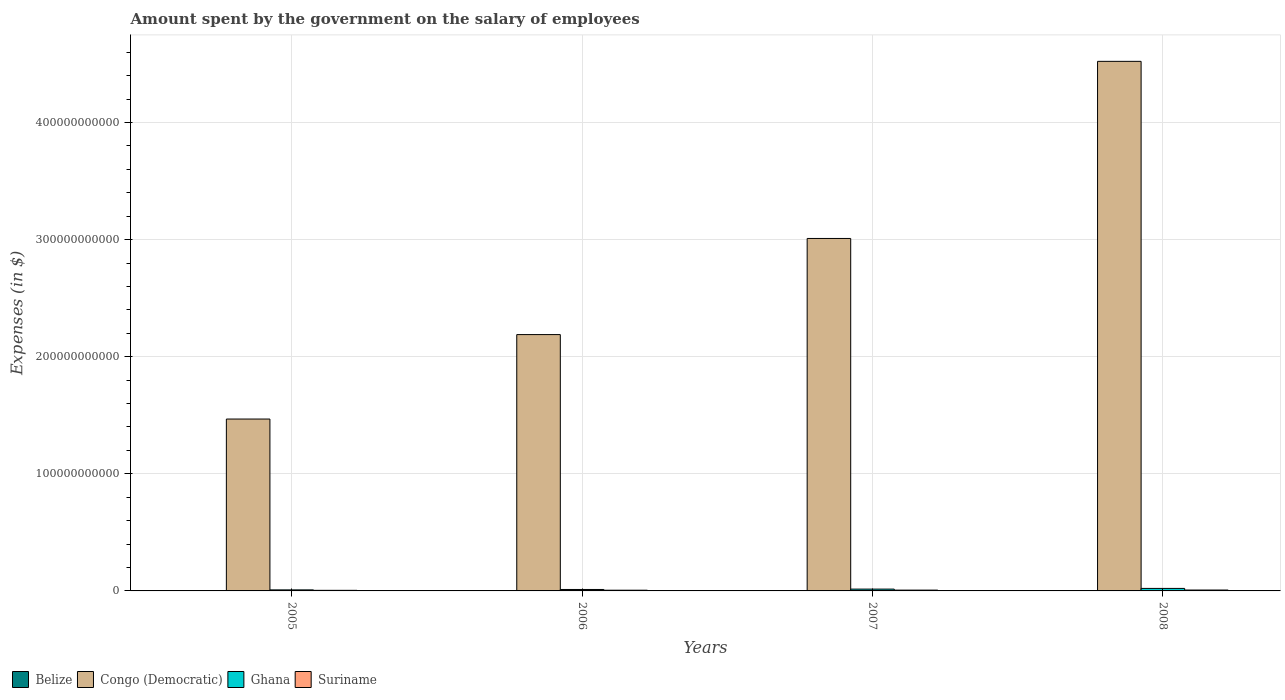How many different coloured bars are there?
Offer a terse response. 4. How many groups of bars are there?
Your answer should be compact. 4. Are the number of bars per tick equal to the number of legend labels?
Your answer should be compact. Yes. Are the number of bars on each tick of the X-axis equal?
Your answer should be very brief. Yes. How many bars are there on the 4th tick from the left?
Provide a short and direct response. 4. How many bars are there on the 4th tick from the right?
Your answer should be compact. 4. What is the amount spent on the salary of employees by the government in Suriname in 2006?
Your answer should be compact. 6.03e+08. Across all years, what is the maximum amount spent on the salary of employees by the government in Ghana?
Your answer should be compact. 2.15e+09. Across all years, what is the minimum amount spent on the salary of employees by the government in Congo (Democratic)?
Make the answer very short. 1.47e+11. What is the total amount spent on the salary of employees by the government in Congo (Democratic) in the graph?
Provide a succinct answer. 1.12e+12. What is the difference between the amount spent on the salary of employees by the government in Suriname in 2006 and that in 2008?
Provide a succinct answer. -1.56e+08. What is the difference between the amount spent on the salary of employees by the government in Suriname in 2008 and the amount spent on the salary of employees by the government in Belize in 2005?
Provide a succinct answer. 5.36e+08. What is the average amount spent on the salary of employees by the government in Belize per year?
Offer a very short reply. 2.32e+08. In the year 2007, what is the difference between the amount spent on the salary of employees by the government in Suriname and amount spent on the salary of employees by the government in Congo (Democratic)?
Provide a succinct answer. -3.00e+11. In how many years, is the amount spent on the salary of employees by the government in Congo (Democratic) greater than 380000000000 $?
Your answer should be compact. 1. What is the ratio of the amount spent on the salary of employees by the government in Ghana in 2005 to that in 2007?
Your answer should be compact. 0.57. Is the amount spent on the salary of employees by the government in Suriname in 2006 less than that in 2007?
Offer a very short reply. Yes. What is the difference between the highest and the second highest amount spent on the salary of employees by the government in Suriname?
Offer a terse response. 6.61e+07. What is the difference between the highest and the lowest amount spent on the salary of employees by the government in Ghana?
Ensure brevity in your answer.  1.26e+09. In how many years, is the amount spent on the salary of employees by the government in Congo (Democratic) greater than the average amount spent on the salary of employees by the government in Congo (Democratic) taken over all years?
Provide a succinct answer. 2. Is the sum of the amount spent on the salary of employees by the government in Belize in 2005 and 2008 greater than the maximum amount spent on the salary of employees by the government in Congo (Democratic) across all years?
Your response must be concise. No. Is it the case that in every year, the sum of the amount spent on the salary of employees by the government in Suriname and amount spent on the salary of employees by the government in Ghana is greater than the sum of amount spent on the salary of employees by the government in Belize and amount spent on the salary of employees by the government in Congo (Democratic)?
Ensure brevity in your answer.  No. What does the 3rd bar from the left in 2006 represents?
Your response must be concise. Ghana. How many bars are there?
Give a very brief answer. 16. Are all the bars in the graph horizontal?
Offer a very short reply. No. How many years are there in the graph?
Provide a succinct answer. 4. What is the difference between two consecutive major ticks on the Y-axis?
Your answer should be compact. 1.00e+11. Does the graph contain grids?
Provide a short and direct response. Yes. What is the title of the graph?
Make the answer very short. Amount spent by the government on the salary of employees. Does "Burkina Faso" appear as one of the legend labels in the graph?
Provide a short and direct response. No. What is the label or title of the Y-axis?
Offer a very short reply. Expenses (in $). What is the Expenses (in $) of Belize in 2005?
Your answer should be compact. 2.23e+08. What is the Expenses (in $) in Congo (Democratic) in 2005?
Provide a short and direct response. 1.47e+11. What is the Expenses (in $) of Ghana in 2005?
Your answer should be compact. 8.87e+08. What is the Expenses (in $) of Suriname in 2005?
Make the answer very short. 5.02e+08. What is the Expenses (in $) of Belize in 2006?
Ensure brevity in your answer.  2.19e+08. What is the Expenses (in $) in Congo (Democratic) in 2006?
Your response must be concise. 2.19e+11. What is the Expenses (in $) in Ghana in 2006?
Offer a very short reply. 1.23e+09. What is the Expenses (in $) of Suriname in 2006?
Ensure brevity in your answer.  6.03e+08. What is the Expenses (in $) of Belize in 2007?
Ensure brevity in your answer.  2.34e+08. What is the Expenses (in $) of Congo (Democratic) in 2007?
Ensure brevity in your answer.  3.01e+11. What is the Expenses (in $) in Ghana in 2007?
Your answer should be compact. 1.55e+09. What is the Expenses (in $) in Suriname in 2007?
Offer a terse response. 6.92e+08. What is the Expenses (in $) in Belize in 2008?
Offer a terse response. 2.50e+08. What is the Expenses (in $) of Congo (Democratic) in 2008?
Offer a very short reply. 4.52e+11. What is the Expenses (in $) in Ghana in 2008?
Your answer should be very brief. 2.15e+09. What is the Expenses (in $) in Suriname in 2008?
Make the answer very short. 7.59e+08. Across all years, what is the maximum Expenses (in $) in Belize?
Provide a short and direct response. 2.50e+08. Across all years, what is the maximum Expenses (in $) in Congo (Democratic)?
Provide a short and direct response. 4.52e+11. Across all years, what is the maximum Expenses (in $) of Ghana?
Provide a succinct answer. 2.15e+09. Across all years, what is the maximum Expenses (in $) of Suriname?
Provide a short and direct response. 7.59e+08. Across all years, what is the minimum Expenses (in $) of Belize?
Your answer should be very brief. 2.19e+08. Across all years, what is the minimum Expenses (in $) in Congo (Democratic)?
Keep it short and to the point. 1.47e+11. Across all years, what is the minimum Expenses (in $) of Ghana?
Provide a succinct answer. 8.87e+08. Across all years, what is the minimum Expenses (in $) in Suriname?
Keep it short and to the point. 5.02e+08. What is the total Expenses (in $) in Belize in the graph?
Your response must be concise. 9.26e+08. What is the total Expenses (in $) of Congo (Democratic) in the graph?
Your response must be concise. 1.12e+12. What is the total Expenses (in $) in Ghana in the graph?
Your answer should be very brief. 5.82e+09. What is the total Expenses (in $) of Suriname in the graph?
Keep it short and to the point. 2.56e+09. What is the difference between the Expenses (in $) in Belize in 2005 and that in 2006?
Your response must be concise. 3.42e+06. What is the difference between the Expenses (in $) of Congo (Democratic) in 2005 and that in 2006?
Offer a very short reply. -7.21e+1. What is the difference between the Expenses (in $) of Ghana in 2005 and that in 2006?
Give a very brief answer. -3.47e+08. What is the difference between the Expenses (in $) in Suriname in 2005 and that in 2006?
Keep it short and to the point. -1.01e+08. What is the difference between the Expenses (in $) of Belize in 2005 and that in 2007?
Your response must be concise. -1.10e+07. What is the difference between the Expenses (in $) of Congo (Democratic) in 2005 and that in 2007?
Provide a short and direct response. -1.54e+11. What is the difference between the Expenses (in $) of Ghana in 2005 and that in 2007?
Your response must be concise. -6.64e+08. What is the difference between the Expenses (in $) in Suriname in 2005 and that in 2007?
Make the answer very short. -1.91e+08. What is the difference between the Expenses (in $) in Belize in 2005 and that in 2008?
Your response must be concise. -2.72e+07. What is the difference between the Expenses (in $) in Congo (Democratic) in 2005 and that in 2008?
Ensure brevity in your answer.  -3.05e+11. What is the difference between the Expenses (in $) in Ghana in 2005 and that in 2008?
Provide a short and direct response. -1.26e+09. What is the difference between the Expenses (in $) of Suriname in 2005 and that in 2008?
Offer a terse response. -2.57e+08. What is the difference between the Expenses (in $) in Belize in 2006 and that in 2007?
Make the answer very short. -1.45e+07. What is the difference between the Expenses (in $) of Congo (Democratic) in 2006 and that in 2007?
Your answer should be compact. -8.21e+1. What is the difference between the Expenses (in $) of Ghana in 2006 and that in 2007?
Provide a succinct answer. -3.17e+08. What is the difference between the Expenses (in $) of Suriname in 2006 and that in 2007?
Make the answer very short. -8.94e+07. What is the difference between the Expenses (in $) in Belize in 2006 and that in 2008?
Offer a terse response. -3.06e+07. What is the difference between the Expenses (in $) in Congo (Democratic) in 2006 and that in 2008?
Ensure brevity in your answer.  -2.33e+11. What is the difference between the Expenses (in $) of Ghana in 2006 and that in 2008?
Offer a very short reply. -9.13e+08. What is the difference between the Expenses (in $) of Suriname in 2006 and that in 2008?
Keep it short and to the point. -1.56e+08. What is the difference between the Expenses (in $) in Belize in 2007 and that in 2008?
Ensure brevity in your answer.  -1.62e+07. What is the difference between the Expenses (in $) of Congo (Democratic) in 2007 and that in 2008?
Your response must be concise. -1.51e+11. What is the difference between the Expenses (in $) in Ghana in 2007 and that in 2008?
Your answer should be compact. -5.95e+08. What is the difference between the Expenses (in $) in Suriname in 2007 and that in 2008?
Your answer should be very brief. -6.61e+07. What is the difference between the Expenses (in $) of Belize in 2005 and the Expenses (in $) of Congo (Democratic) in 2006?
Your answer should be very brief. -2.19e+11. What is the difference between the Expenses (in $) of Belize in 2005 and the Expenses (in $) of Ghana in 2006?
Ensure brevity in your answer.  -1.01e+09. What is the difference between the Expenses (in $) in Belize in 2005 and the Expenses (in $) in Suriname in 2006?
Give a very brief answer. -3.80e+08. What is the difference between the Expenses (in $) of Congo (Democratic) in 2005 and the Expenses (in $) of Ghana in 2006?
Offer a very short reply. 1.46e+11. What is the difference between the Expenses (in $) of Congo (Democratic) in 2005 and the Expenses (in $) of Suriname in 2006?
Keep it short and to the point. 1.46e+11. What is the difference between the Expenses (in $) of Ghana in 2005 and the Expenses (in $) of Suriname in 2006?
Give a very brief answer. 2.84e+08. What is the difference between the Expenses (in $) in Belize in 2005 and the Expenses (in $) in Congo (Democratic) in 2007?
Offer a very short reply. -3.01e+11. What is the difference between the Expenses (in $) of Belize in 2005 and the Expenses (in $) of Ghana in 2007?
Provide a short and direct response. -1.33e+09. What is the difference between the Expenses (in $) of Belize in 2005 and the Expenses (in $) of Suriname in 2007?
Offer a very short reply. -4.70e+08. What is the difference between the Expenses (in $) of Congo (Democratic) in 2005 and the Expenses (in $) of Ghana in 2007?
Give a very brief answer. 1.45e+11. What is the difference between the Expenses (in $) of Congo (Democratic) in 2005 and the Expenses (in $) of Suriname in 2007?
Keep it short and to the point. 1.46e+11. What is the difference between the Expenses (in $) of Ghana in 2005 and the Expenses (in $) of Suriname in 2007?
Offer a terse response. 1.95e+08. What is the difference between the Expenses (in $) in Belize in 2005 and the Expenses (in $) in Congo (Democratic) in 2008?
Your answer should be compact. -4.52e+11. What is the difference between the Expenses (in $) in Belize in 2005 and the Expenses (in $) in Ghana in 2008?
Make the answer very short. -1.92e+09. What is the difference between the Expenses (in $) of Belize in 2005 and the Expenses (in $) of Suriname in 2008?
Keep it short and to the point. -5.36e+08. What is the difference between the Expenses (in $) of Congo (Democratic) in 2005 and the Expenses (in $) of Ghana in 2008?
Your response must be concise. 1.45e+11. What is the difference between the Expenses (in $) in Congo (Democratic) in 2005 and the Expenses (in $) in Suriname in 2008?
Provide a short and direct response. 1.46e+11. What is the difference between the Expenses (in $) in Ghana in 2005 and the Expenses (in $) in Suriname in 2008?
Make the answer very short. 1.29e+08. What is the difference between the Expenses (in $) in Belize in 2006 and the Expenses (in $) in Congo (Democratic) in 2007?
Your answer should be very brief. -3.01e+11. What is the difference between the Expenses (in $) of Belize in 2006 and the Expenses (in $) of Ghana in 2007?
Give a very brief answer. -1.33e+09. What is the difference between the Expenses (in $) in Belize in 2006 and the Expenses (in $) in Suriname in 2007?
Your response must be concise. -4.73e+08. What is the difference between the Expenses (in $) of Congo (Democratic) in 2006 and the Expenses (in $) of Ghana in 2007?
Provide a short and direct response. 2.17e+11. What is the difference between the Expenses (in $) in Congo (Democratic) in 2006 and the Expenses (in $) in Suriname in 2007?
Offer a terse response. 2.18e+11. What is the difference between the Expenses (in $) of Ghana in 2006 and the Expenses (in $) of Suriname in 2007?
Ensure brevity in your answer.  5.42e+08. What is the difference between the Expenses (in $) in Belize in 2006 and the Expenses (in $) in Congo (Democratic) in 2008?
Give a very brief answer. -4.52e+11. What is the difference between the Expenses (in $) of Belize in 2006 and the Expenses (in $) of Ghana in 2008?
Your answer should be very brief. -1.93e+09. What is the difference between the Expenses (in $) of Belize in 2006 and the Expenses (in $) of Suriname in 2008?
Your response must be concise. -5.39e+08. What is the difference between the Expenses (in $) in Congo (Democratic) in 2006 and the Expenses (in $) in Ghana in 2008?
Keep it short and to the point. 2.17e+11. What is the difference between the Expenses (in $) of Congo (Democratic) in 2006 and the Expenses (in $) of Suriname in 2008?
Offer a very short reply. 2.18e+11. What is the difference between the Expenses (in $) of Ghana in 2006 and the Expenses (in $) of Suriname in 2008?
Provide a short and direct response. 4.76e+08. What is the difference between the Expenses (in $) in Belize in 2007 and the Expenses (in $) in Congo (Democratic) in 2008?
Offer a terse response. -4.52e+11. What is the difference between the Expenses (in $) in Belize in 2007 and the Expenses (in $) in Ghana in 2008?
Offer a terse response. -1.91e+09. What is the difference between the Expenses (in $) in Belize in 2007 and the Expenses (in $) in Suriname in 2008?
Your answer should be compact. -5.25e+08. What is the difference between the Expenses (in $) in Congo (Democratic) in 2007 and the Expenses (in $) in Ghana in 2008?
Your answer should be compact. 2.99e+11. What is the difference between the Expenses (in $) in Congo (Democratic) in 2007 and the Expenses (in $) in Suriname in 2008?
Your answer should be compact. 3.00e+11. What is the difference between the Expenses (in $) of Ghana in 2007 and the Expenses (in $) of Suriname in 2008?
Offer a terse response. 7.93e+08. What is the average Expenses (in $) in Belize per year?
Your response must be concise. 2.32e+08. What is the average Expenses (in $) in Congo (Democratic) per year?
Ensure brevity in your answer.  2.80e+11. What is the average Expenses (in $) in Ghana per year?
Make the answer very short. 1.46e+09. What is the average Expenses (in $) in Suriname per year?
Your answer should be very brief. 6.39e+08. In the year 2005, what is the difference between the Expenses (in $) in Belize and Expenses (in $) in Congo (Democratic)?
Make the answer very short. -1.47e+11. In the year 2005, what is the difference between the Expenses (in $) in Belize and Expenses (in $) in Ghana?
Provide a succinct answer. -6.65e+08. In the year 2005, what is the difference between the Expenses (in $) of Belize and Expenses (in $) of Suriname?
Your answer should be compact. -2.79e+08. In the year 2005, what is the difference between the Expenses (in $) in Congo (Democratic) and Expenses (in $) in Ghana?
Your response must be concise. 1.46e+11. In the year 2005, what is the difference between the Expenses (in $) of Congo (Democratic) and Expenses (in $) of Suriname?
Your answer should be compact. 1.46e+11. In the year 2005, what is the difference between the Expenses (in $) of Ghana and Expenses (in $) of Suriname?
Give a very brief answer. 3.86e+08. In the year 2006, what is the difference between the Expenses (in $) of Belize and Expenses (in $) of Congo (Democratic)?
Ensure brevity in your answer.  -2.19e+11. In the year 2006, what is the difference between the Expenses (in $) in Belize and Expenses (in $) in Ghana?
Keep it short and to the point. -1.02e+09. In the year 2006, what is the difference between the Expenses (in $) in Belize and Expenses (in $) in Suriname?
Make the answer very short. -3.84e+08. In the year 2006, what is the difference between the Expenses (in $) in Congo (Democratic) and Expenses (in $) in Ghana?
Your answer should be very brief. 2.18e+11. In the year 2006, what is the difference between the Expenses (in $) in Congo (Democratic) and Expenses (in $) in Suriname?
Offer a very short reply. 2.18e+11. In the year 2006, what is the difference between the Expenses (in $) in Ghana and Expenses (in $) in Suriname?
Give a very brief answer. 6.32e+08. In the year 2007, what is the difference between the Expenses (in $) of Belize and Expenses (in $) of Congo (Democratic)?
Keep it short and to the point. -3.01e+11. In the year 2007, what is the difference between the Expenses (in $) of Belize and Expenses (in $) of Ghana?
Keep it short and to the point. -1.32e+09. In the year 2007, what is the difference between the Expenses (in $) of Belize and Expenses (in $) of Suriname?
Give a very brief answer. -4.59e+08. In the year 2007, what is the difference between the Expenses (in $) of Congo (Democratic) and Expenses (in $) of Ghana?
Your answer should be compact. 2.99e+11. In the year 2007, what is the difference between the Expenses (in $) of Congo (Democratic) and Expenses (in $) of Suriname?
Your answer should be very brief. 3.00e+11. In the year 2007, what is the difference between the Expenses (in $) of Ghana and Expenses (in $) of Suriname?
Offer a very short reply. 8.59e+08. In the year 2008, what is the difference between the Expenses (in $) of Belize and Expenses (in $) of Congo (Democratic)?
Ensure brevity in your answer.  -4.52e+11. In the year 2008, what is the difference between the Expenses (in $) of Belize and Expenses (in $) of Ghana?
Make the answer very short. -1.90e+09. In the year 2008, what is the difference between the Expenses (in $) in Belize and Expenses (in $) in Suriname?
Make the answer very short. -5.08e+08. In the year 2008, what is the difference between the Expenses (in $) in Congo (Democratic) and Expenses (in $) in Ghana?
Offer a very short reply. 4.50e+11. In the year 2008, what is the difference between the Expenses (in $) in Congo (Democratic) and Expenses (in $) in Suriname?
Keep it short and to the point. 4.51e+11. In the year 2008, what is the difference between the Expenses (in $) in Ghana and Expenses (in $) in Suriname?
Your answer should be compact. 1.39e+09. What is the ratio of the Expenses (in $) of Belize in 2005 to that in 2006?
Offer a terse response. 1.02. What is the ratio of the Expenses (in $) in Congo (Democratic) in 2005 to that in 2006?
Your answer should be very brief. 0.67. What is the ratio of the Expenses (in $) in Ghana in 2005 to that in 2006?
Provide a succinct answer. 0.72. What is the ratio of the Expenses (in $) of Suriname in 2005 to that in 2006?
Your answer should be very brief. 0.83. What is the ratio of the Expenses (in $) of Belize in 2005 to that in 2007?
Your answer should be very brief. 0.95. What is the ratio of the Expenses (in $) in Congo (Democratic) in 2005 to that in 2007?
Give a very brief answer. 0.49. What is the ratio of the Expenses (in $) in Ghana in 2005 to that in 2007?
Offer a very short reply. 0.57. What is the ratio of the Expenses (in $) of Suriname in 2005 to that in 2007?
Offer a terse response. 0.72. What is the ratio of the Expenses (in $) in Belize in 2005 to that in 2008?
Offer a terse response. 0.89. What is the ratio of the Expenses (in $) of Congo (Democratic) in 2005 to that in 2008?
Ensure brevity in your answer.  0.32. What is the ratio of the Expenses (in $) of Ghana in 2005 to that in 2008?
Make the answer very short. 0.41. What is the ratio of the Expenses (in $) of Suriname in 2005 to that in 2008?
Your answer should be compact. 0.66. What is the ratio of the Expenses (in $) of Belize in 2006 to that in 2007?
Offer a very short reply. 0.94. What is the ratio of the Expenses (in $) of Congo (Democratic) in 2006 to that in 2007?
Provide a short and direct response. 0.73. What is the ratio of the Expenses (in $) in Ghana in 2006 to that in 2007?
Your answer should be compact. 0.8. What is the ratio of the Expenses (in $) in Suriname in 2006 to that in 2007?
Keep it short and to the point. 0.87. What is the ratio of the Expenses (in $) of Belize in 2006 to that in 2008?
Your response must be concise. 0.88. What is the ratio of the Expenses (in $) of Congo (Democratic) in 2006 to that in 2008?
Provide a short and direct response. 0.48. What is the ratio of the Expenses (in $) in Ghana in 2006 to that in 2008?
Your response must be concise. 0.57. What is the ratio of the Expenses (in $) in Suriname in 2006 to that in 2008?
Ensure brevity in your answer.  0.8. What is the ratio of the Expenses (in $) of Belize in 2007 to that in 2008?
Provide a short and direct response. 0.94. What is the ratio of the Expenses (in $) in Congo (Democratic) in 2007 to that in 2008?
Make the answer very short. 0.67. What is the ratio of the Expenses (in $) in Ghana in 2007 to that in 2008?
Offer a terse response. 0.72. What is the ratio of the Expenses (in $) in Suriname in 2007 to that in 2008?
Make the answer very short. 0.91. What is the difference between the highest and the second highest Expenses (in $) in Belize?
Make the answer very short. 1.62e+07. What is the difference between the highest and the second highest Expenses (in $) of Congo (Democratic)?
Provide a succinct answer. 1.51e+11. What is the difference between the highest and the second highest Expenses (in $) of Ghana?
Offer a terse response. 5.95e+08. What is the difference between the highest and the second highest Expenses (in $) of Suriname?
Your answer should be very brief. 6.61e+07. What is the difference between the highest and the lowest Expenses (in $) of Belize?
Offer a terse response. 3.06e+07. What is the difference between the highest and the lowest Expenses (in $) of Congo (Democratic)?
Offer a terse response. 3.05e+11. What is the difference between the highest and the lowest Expenses (in $) in Ghana?
Your answer should be compact. 1.26e+09. What is the difference between the highest and the lowest Expenses (in $) in Suriname?
Provide a succinct answer. 2.57e+08. 